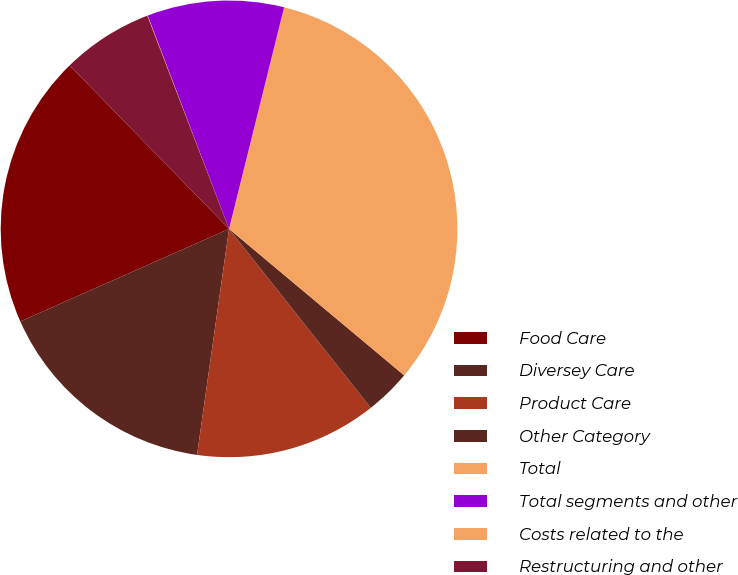<chart> <loc_0><loc_0><loc_500><loc_500><pie_chart><fcel>Food Care<fcel>Diversey Care<fcel>Product Care<fcel>Other Category<fcel>Total<fcel>Total segments and other<fcel>Costs related to the<fcel>Restructuring and other<nl><fcel>19.34%<fcel>16.12%<fcel>12.9%<fcel>3.25%<fcel>32.21%<fcel>9.68%<fcel>0.03%<fcel>6.47%<nl></chart> 